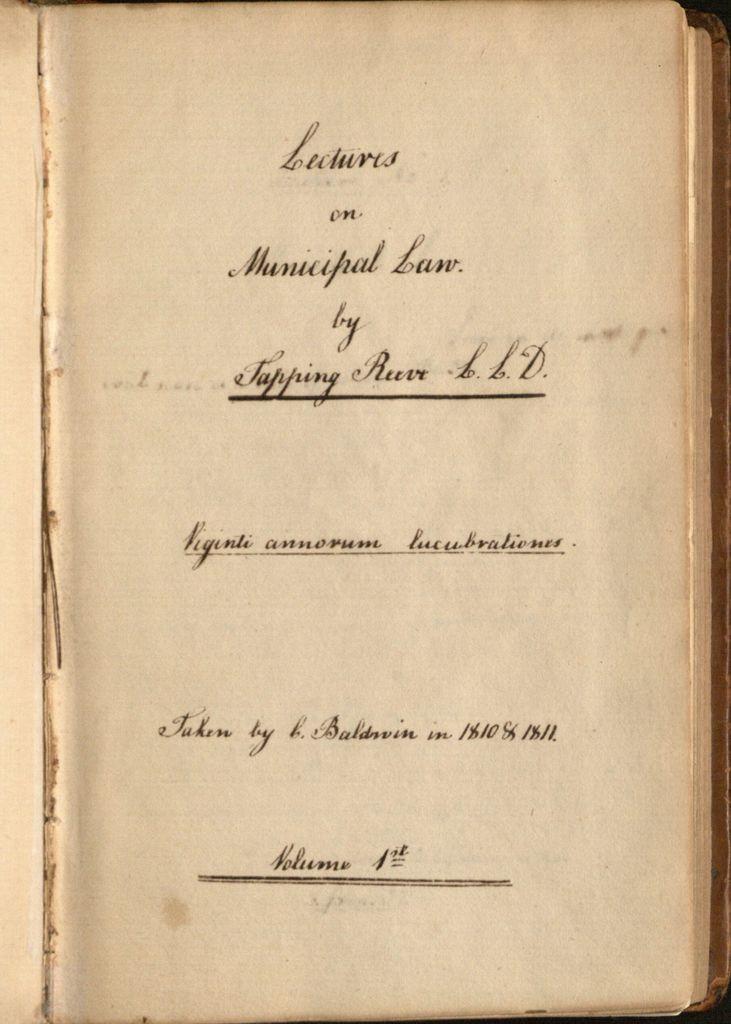Which volume is this book?
Offer a very short reply. 1st. What is the title of this book?
Make the answer very short. Lectures on municipal law. 